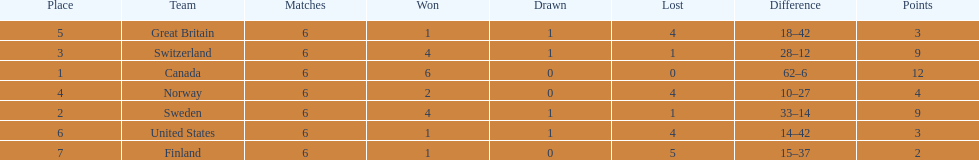Between switzerland and great britain, who had a superior performance in the 1951 world ice hockey championships? Switzerland. 